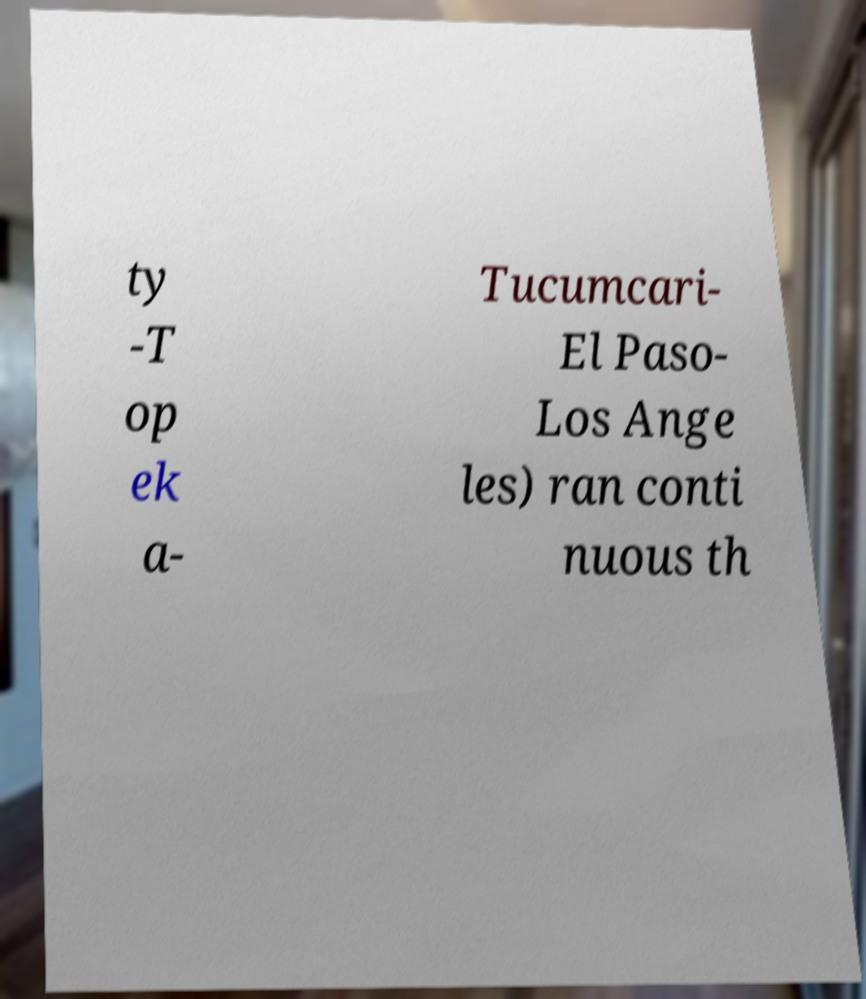For documentation purposes, I need the text within this image transcribed. Could you provide that? ty -T op ek a- Tucumcari- El Paso- Los Ange les) ran conti nuous th 